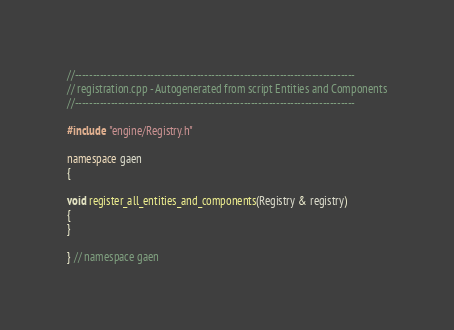<code> <loc_0><loc_0><loc_500><loc_500><_C++_>//------------------------------------------------------------------------------
// registration.cpp - Autogenerated from script Entities and Components
//------------------------------------------------------------------------------

#include "engine/Registry.h"

namespace gaen
{

void register_all_entities_and_components(Registry & registry)
{
}

} // namespace gaen
</code> 